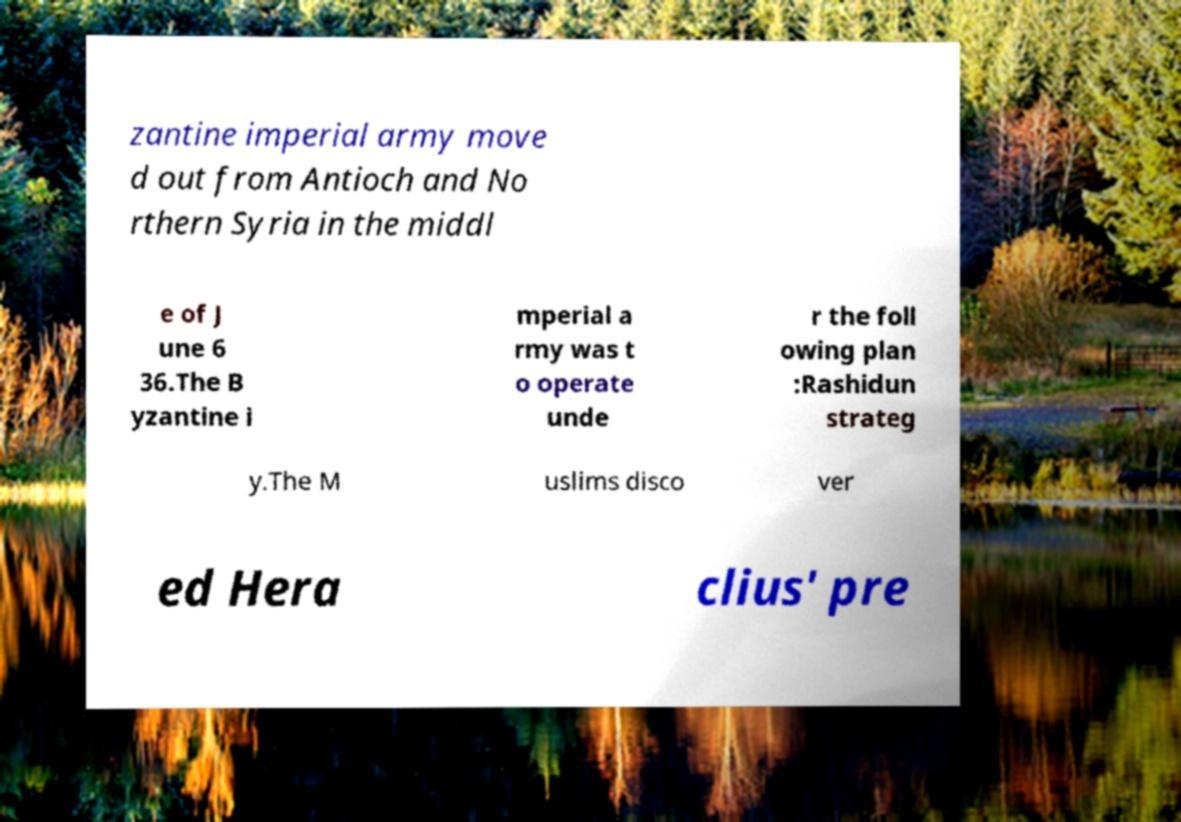Can you accurately transcribe the text from the provided image for me? zantine imperial army move d out from Antioch and No rthern Syria in the middl e of J une 6 36.The B yzantine i mperial a rmy was t o operate unde r the foll owing plan :Rashidun strateg y.The M uslims disco ver ed Hera clius' pre 